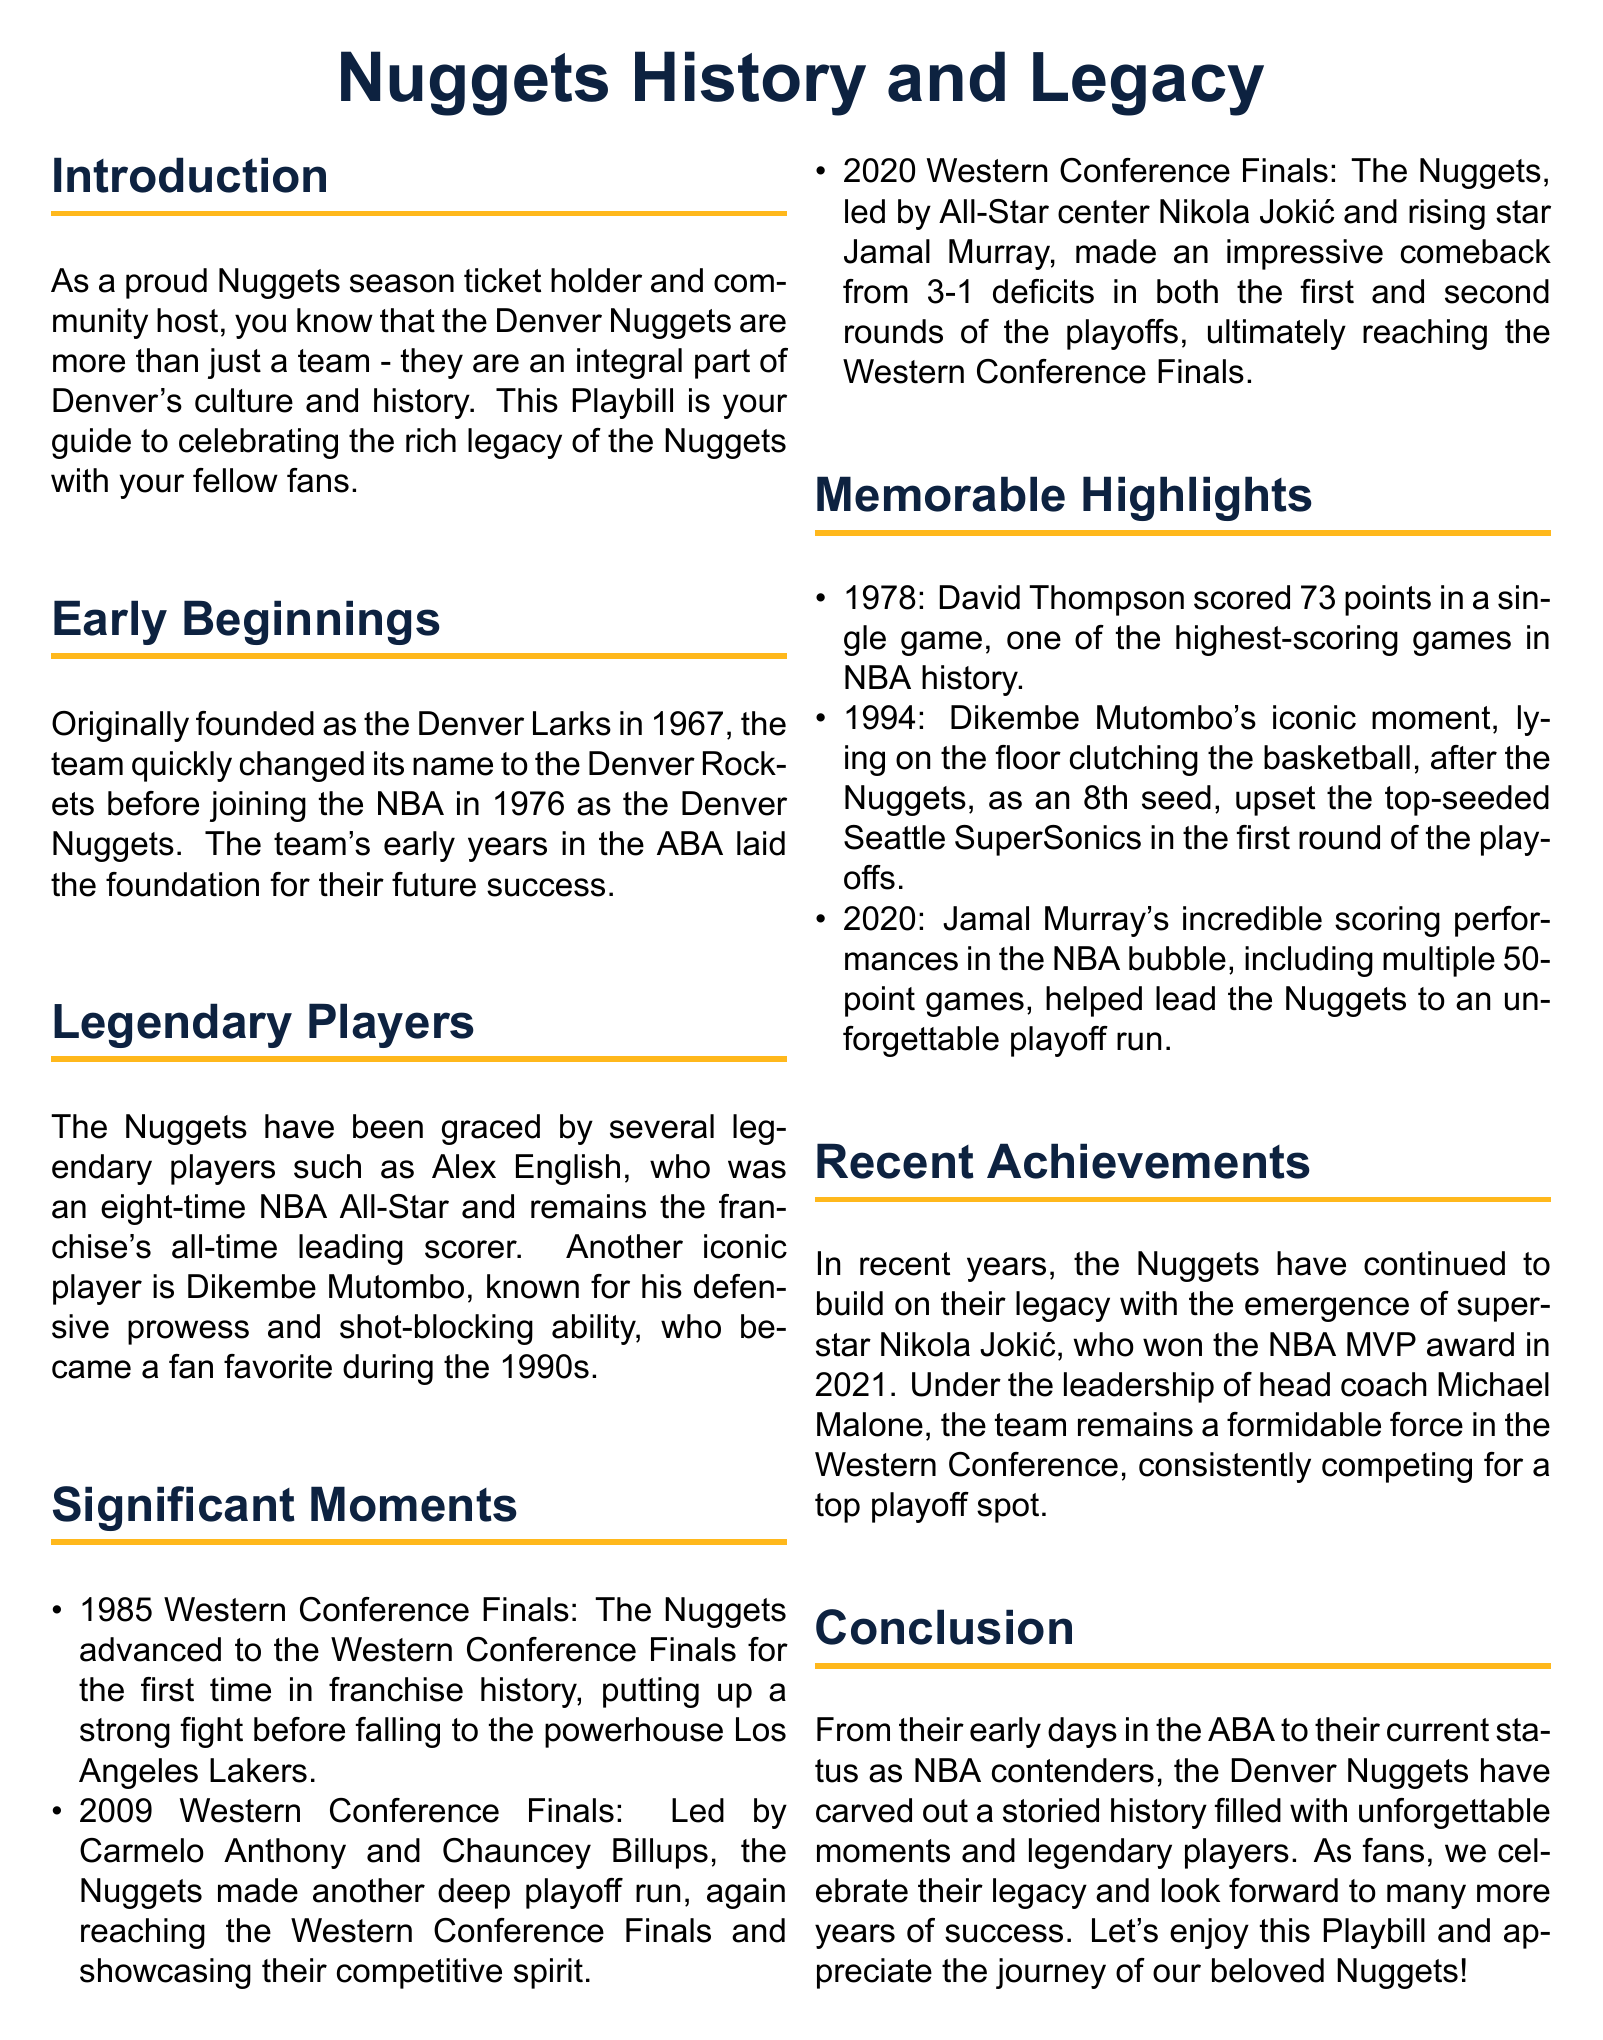What was the original name of the Nuggets? The document states that the team was originally founded as the Denver Larks in 1967.
Answer: Denver Larks Who is the all-time leading scorer for the Nuggets? According to the document, Alex English remains the franchise's all-time leading scorer.
Answer: Alex English What significant playoff achievement happened in 1985? The document mentions that in 1985, the Nuggets advanced to the Western Conference Finals for the first time in franchise history.
Answer: Western Conference Finals How many points did David Thompson score in 1978? The document notes that David Thompson scored 73 points in a single game in 1978.
Answer: 73 points Which player won the NBA MVP award in 2021? The document states that Nikola Jokić won the NBA MVP award in 2021.
Answer: Nikola Jokić What was the notable upset the Nuggets achieved in 1994? The document cites that in 1994, the Nuggets, as an 8th seed, upset the top-seeded Seattle SuperSonics in the first round of the playoffs.
Answer: Upset the Seattle SuperSonics What year did the Nuggets reach the Western Conference Finals with Carmelo Anthony? The document indicates that the Nuggets reached the Western Conference Finals in 2009, led by Carmelo Anthony and Chauncey Billups.
Answer: 2009 What color is referred to as Nuggets Gold in the document? The document describes Nuggets Gold with the RGB value of 255,184,28.
Answer: RGB(255,184,28) What key transition did the team undergo in its early years? The document mentions that the team changed its name from the Denver Rockets before joining the NBA in 1976 as the Denver Nuggets.
Answer: Changed its name to Denver Nuggets 